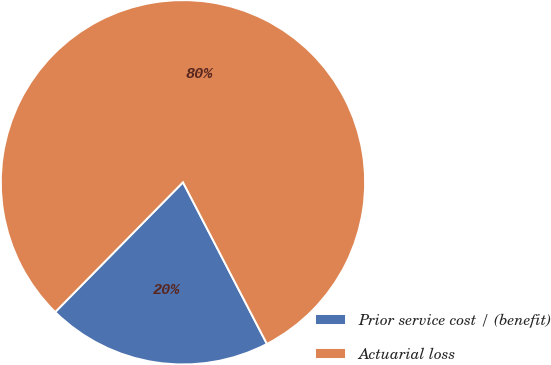Convert chart. <chart><loc_0><loc_0><loc_500><loc_500><pie_chart><fcel>Prior service cost / (benefit)<fcel>Actuarial loss<nl><fcel>20.0%<fcel>80.0%<nl></chart> 